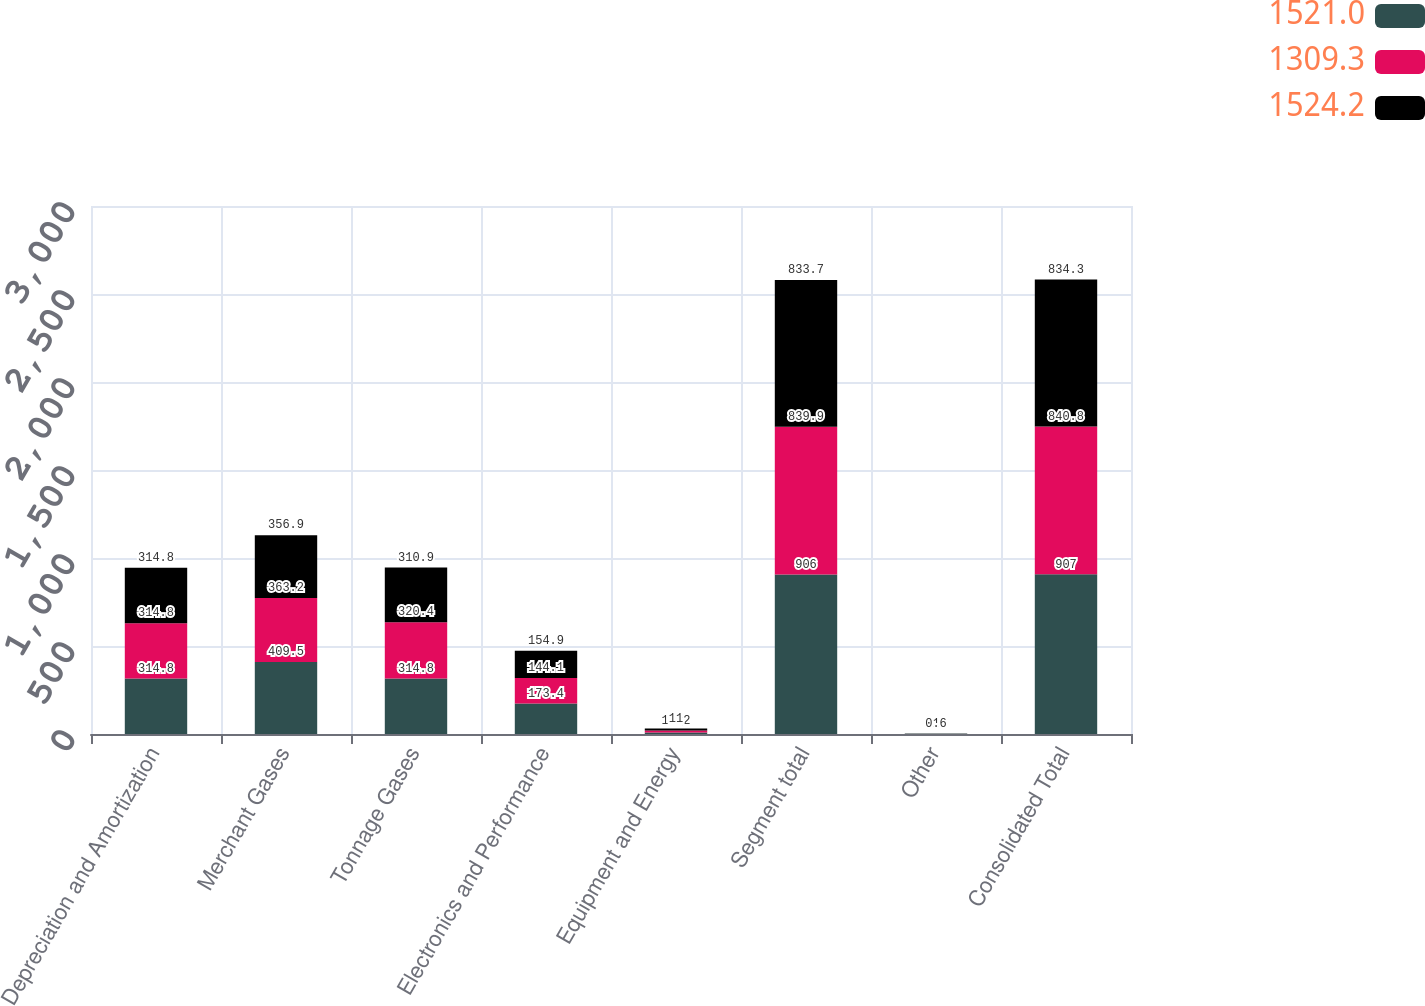Convert chart. <chart><loc_0><loc_0><loc_500><loc_500><stacked_bar_chart><ecel><fcel>Depreciation and Amortization<fcel>Merchant Gases<fcel>Tonnage Gases<fcel>Electronics and Performance<fcel>Equipment and Energy<fcel>Segment total<fcel>Other<fcel>Consolidated Total<nl><fcel>1521<fcel>314.8<fcel>409.5<fcel>314.8<fcel>173.4<fcel>8.3<fcel>906<fcel>1<fcel>907<nl><fcel>1309.3<fcel>314.8<fcel>363.2<fcel>320.4<fcel>144.1<fcel>12.2<fcel>839.9<fcel>0.9<fcel>840.8<nl><fcel>1524.2<fcel>314.8<fcel>356.9<fcel>310.9<fcel>154.9<fcel>11<fcel>833.7<fcel>0.6<fcel>834.3<nl></chart> 